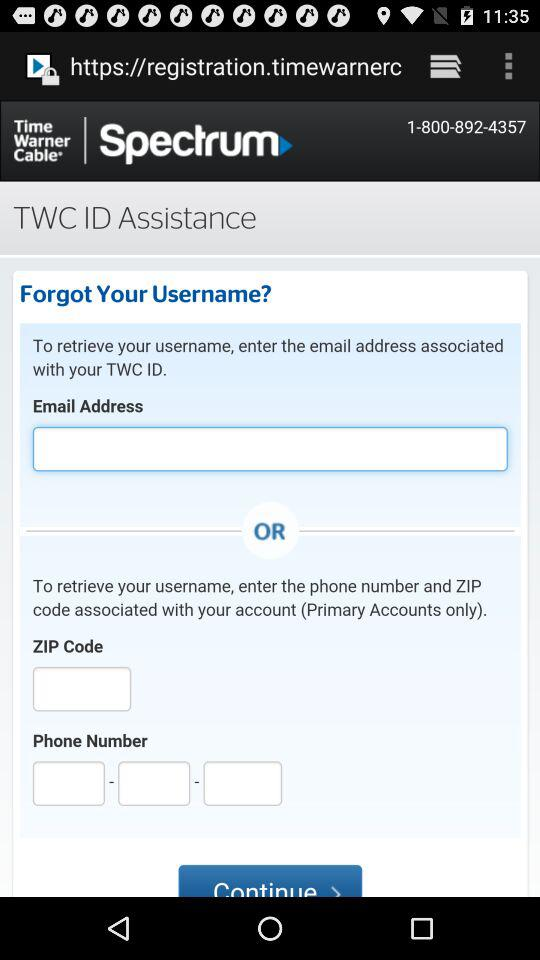How many text inputs are there for the phone number field?
Answer the question using a single word or phrase. 3 